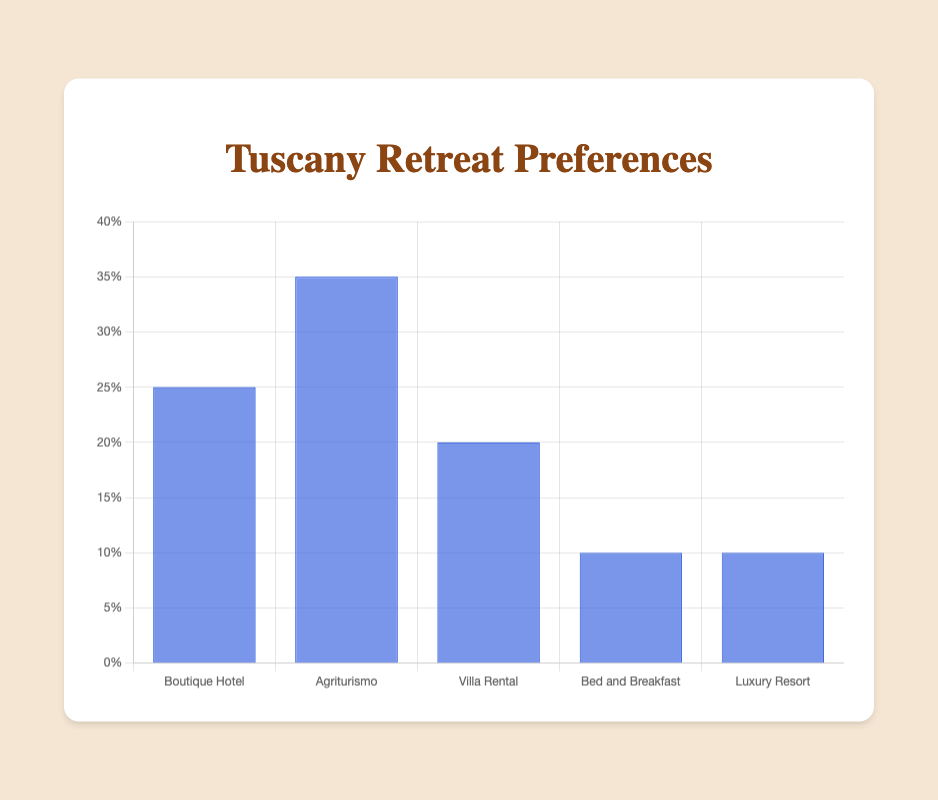What percentage of preferences does Agriturismo have? In the figure, locate the bar labeled 'Agriturismo' and read its percentage value.
Answer: 35% Which accommodation type has the least preference? Identify the shortest bar in the chart, which represents the accommodation type with the least preference. This bar is 'Bed and Breakfast' and 'Luxury Resort.'
Answer: Bed and Breakfast and Luxury Resort What's the difference in preference percentages between Boutique Hotel and Villa Rental? Locate the bars for Boutique Hotel and Villa Rental, then subtract the percentage of Villa Rental from Boutique Hotel (25% - 20% = 5%).
Answer: 5% What is the sum of the preferences for Luxury Resort and Bed and Breakfast? Locate the bars for Luxury Resort and Bed and Breakfast, then sum their percentages (10% + 10% = 20%).
Answer: 20% Which accommodation type shows the highest preference? Identify the tallest bar in the chart, which represents the accommodation type with the highest preference, i.e., Agriturismo.
Answer: Agriturismo What's the total percentage for Boutique Hotel and Agriturismo combined? Add the percentages for Boutique Hotel and Agriturismo (25% + 35% = 60%).
Answer: 60% How does the preference for Villa Rental compare to that of Agriturismo? Compare the heights of the bars representing Villa Rental (20%) and Agriturismo (35%). Villa Rental has a lower preference.
Answer: Villa Rental has a lower preference What are the two most preferred accommodation types? Identify the two tallest bars in the chart, which represent Agriturismo (35%) and Boutique Hotel (25%).
Answer: Agriturismo and Boutique Hotel If you were to select randomly, what is the likelihood (in percentage) that someone prefers either a Bed and Breakfast or a Luxury Resort? Add the percentages for Bed and Breakfast and Luxury Resort (10% + 10% = 20%).
Answer: 20% What is the mean (average) preference value of all accommodation types? Sum the percentages of all five accommodation types and divide by 5: (25% + 35% + 20% + 10% + 10%) / 5 = 20%.
Answer: 20% 